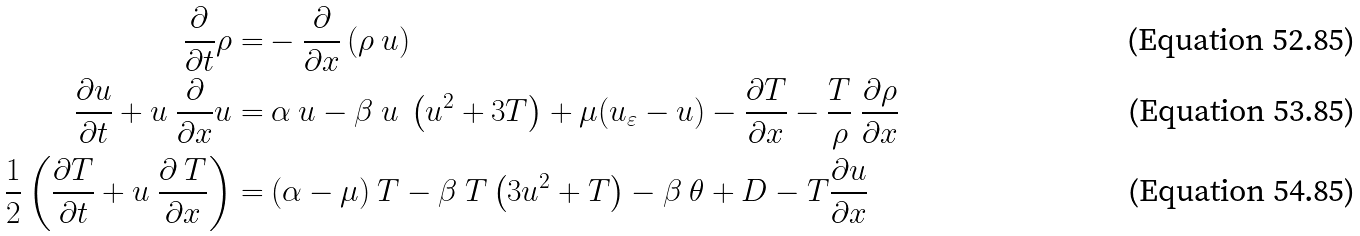Convert formula to latex. <formula><loc_0><loc_0><loc_500><loc_500>\frac { \partial } { \partial t } \rho = & - \frac { \partial } { \partial x } \left ( \rho \ u \right ) \\ \frac { \partial u } { \partial t } + u \ \frac { \partial } { \partial x } u = & \ \alpha \ u - \beta \ u \ \left ( u ^ { 2 } + 3 T \right ) + \mu ( u _ { \varepsilon } - u ) - \frac { \partial T } { \partial x } - \frac { T } { \rho } \ \frac { \partial \rho } { \partial x } \\ \frac { 1 } { 2 } \left ( \frac { \partial T } { \partial t } + u \ \frac { \partial \ T } { \partial x } \right ) = & \ ( \alpha - \mu ) \ T - \beta \ T \left ( 3 u ^ { 2 } + T \right ) - \beta \ \theta + D - T \frac { \partial u } { \partial x }</formula> 